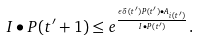<formula> <loc_0><loc_0><loc_500><loc_500>I \bullet P ( t ^ { \prime } + 1 ) \leq e ^ { \frac { \epsilon \delta ( t ^ { \prime } ) P ( t ^ { \prime } ) \bullet A _ { i ( t ^ { \prime } ) } } { I \bullet P ( t ^ { \prime } ) } } .</formula> 